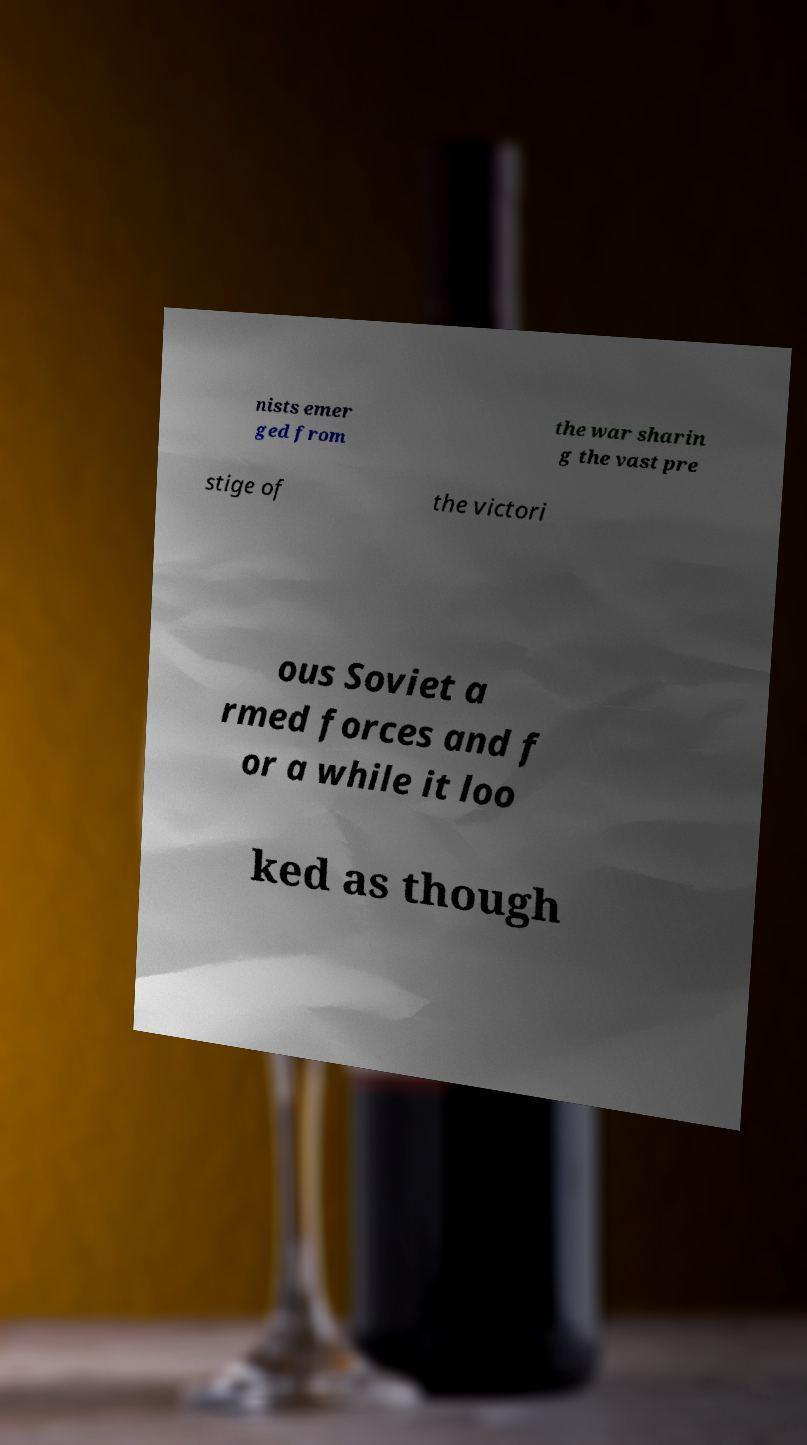For documentation purposes, I need the text within this image transcribed. Could you provide that? nists emer ged from the war sharin g the vast pre stige of the victori ous Soviet a rmed forces and f or a while it loo ked as though 